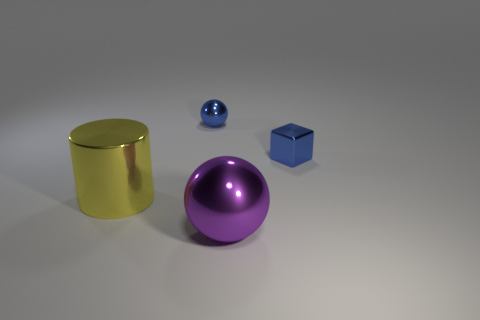Add 2 large purple metallic spheres. How many objects exist? 6 Subtract all blue balls. How many balls are left? 1 Subtract 1 spheres. How many spheres are left? 1 Subtract all cyan balls. Subtract all blue cylinders. How many balls are left? 2 Subtract all green blocks. How many brown cylinders are left? 0 Subtract all big red metal spheres. Subtract all shiny balls. How many objects are left? 2 Add 4 big metal cylinders. How many big metal cylinders are left? 5 Add 3 blue shiny balls. How many blue shiny balls exist? 4 Subtract 0 yellow blocks. How many objects are left? 4 Subtract all cylinders. How many objects are left? 3 